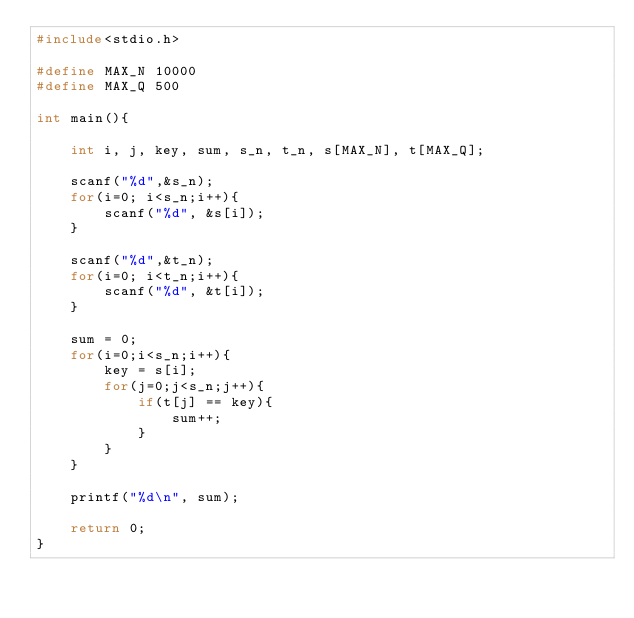Convert code to text. <code><loc_0><loc_0><loc_500><loc_500><_C_>#include<stdio.h>

#define MAX_N 10000
#define MAX_Q 500

int main(){

    int i, j, key, sum, s_n, t_n, s[MAX_N], t[MAX_Q];

    scanf("%d",&s_n);
    for(i=0; i<s_n;i++){
        scanf("%d", &s[i]);
    }

    scanf("%d",&t_n);
    for(i=0; i<t_n;i++){
        scanf("%d", &t[i]);
    }

    sum = 0;
    for(i=0;i<s_n;i++){
        key = s[i];
        for(j=0;j<s_n;j++){
            if(t[j] == key){
                sum++;
            }
        }
    }

    printf("%d\n", sum);
   
    return 0;
}</code> 